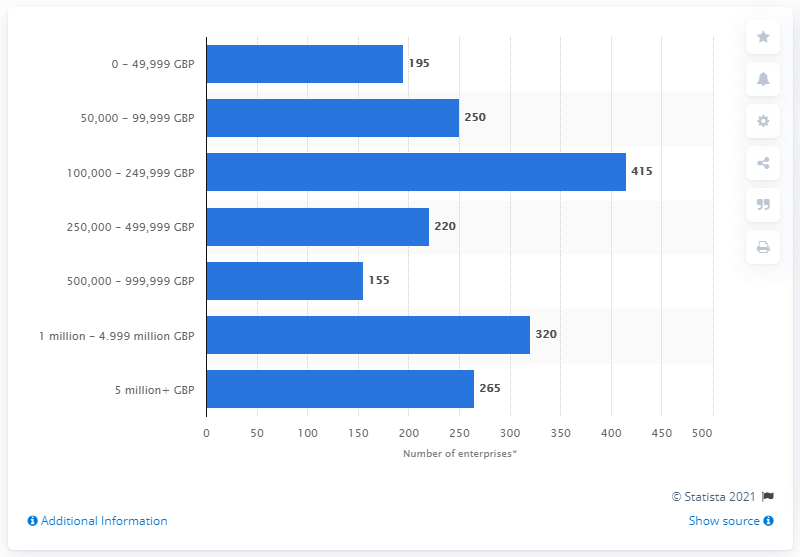Draw attention to some important aspects in this diagram. As of March 2020, there were 265 enterprises in the basic metals manufacturing industry that had a turnover of more than 5 million GBP. 